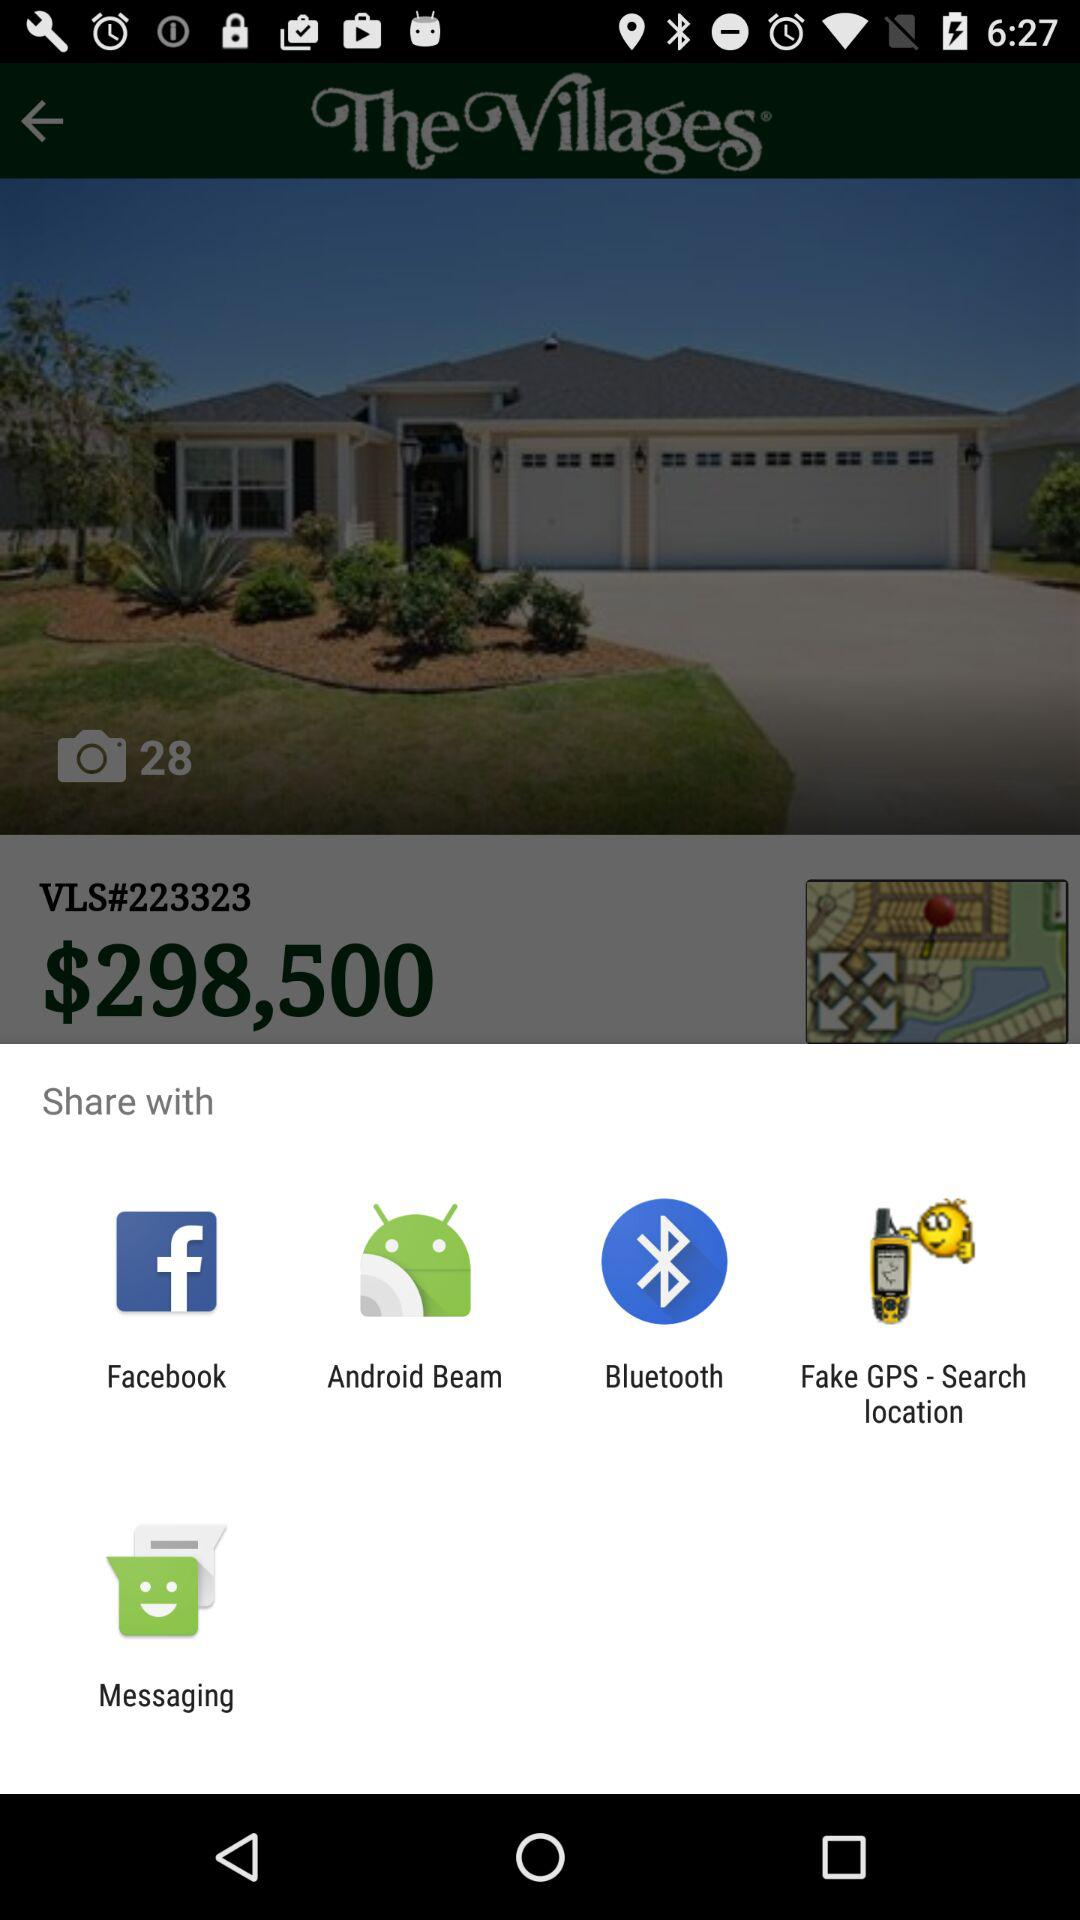What are the different applications that can be used to share? The different applications that can be used to share are "Facebook", "Android Beam", "Bluetooth", "Fake GPS - Search location" and "Messaging". 